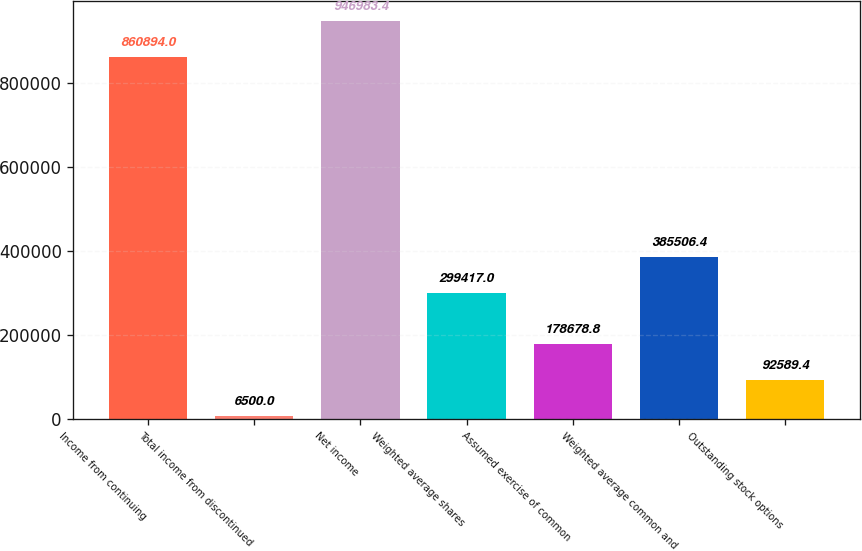Convert chart. <chart><loc_0><loc_0><loc_500><loc_500><bar_chart><fcel>Income from continuing<fcel>Total income from discontinued<fcel>Net income<fcel>Weighted average shares<fcel>Assumed exercise of common<fcel>Weighted average common and<fcel>Outstanding stock options<nl><fcel>860894<fcel>6500<fcel>946983<fcel>299417<fcel>178679<fcel>385506<fcel>92589.4<nl></chart> 